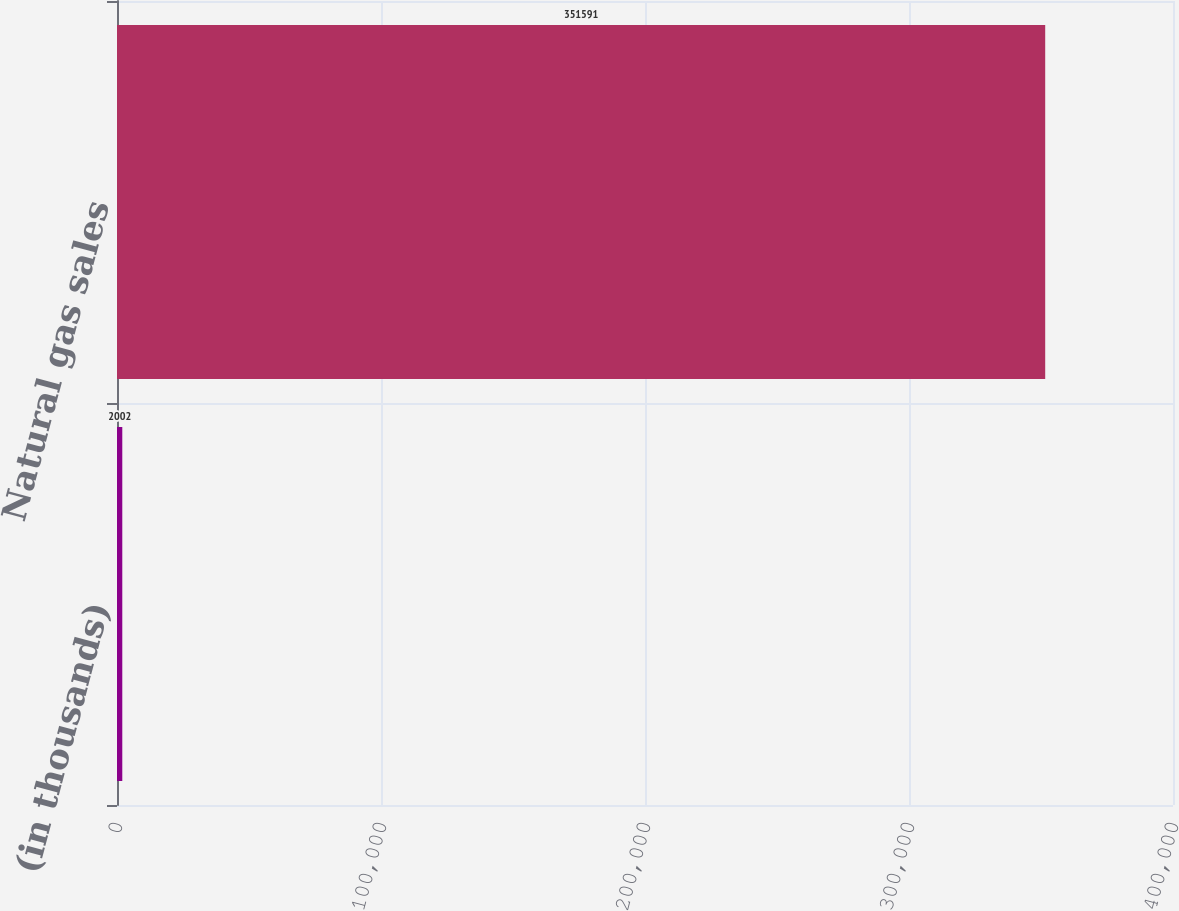<chart> <loc_0><loc_0><loc_500><loc_500><bar_chart><fcel>(in thousands)<fcel>Natural gas sales<nl><fcel>2002<fcel>351591<nl></chart> 